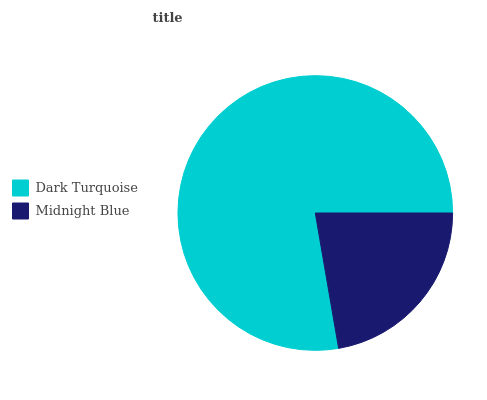Is Midnight Blue the minimum?
Answer yes or no. Yes. Is Dark Turquoise the maximum?
Answer yes or no. Yes. Is Midnight Blue the maximum?
Answer yes or no. No. Is Dark Turquoise greater than Midnight Blue?
Answer yes or no. Yes. Is Midnight Blue less than Dark Turquoise?
Answer yes or no. Yes. Is Midnight Blue greater than Dark Turquoise?
Answer yes or no. No. Is Dark Turquoise less than Midnight Blue?
Answer yes or no. No. Is Dark Turquoise the high median?
Answer yes or no. Yes. Is Midnight Blue the low median?
Answer yes or no. Yes. Is Midnight Blue the high median?
Answer yes or no. No. Is Dark Turquoise the low median?
Answer yes or no. No. 